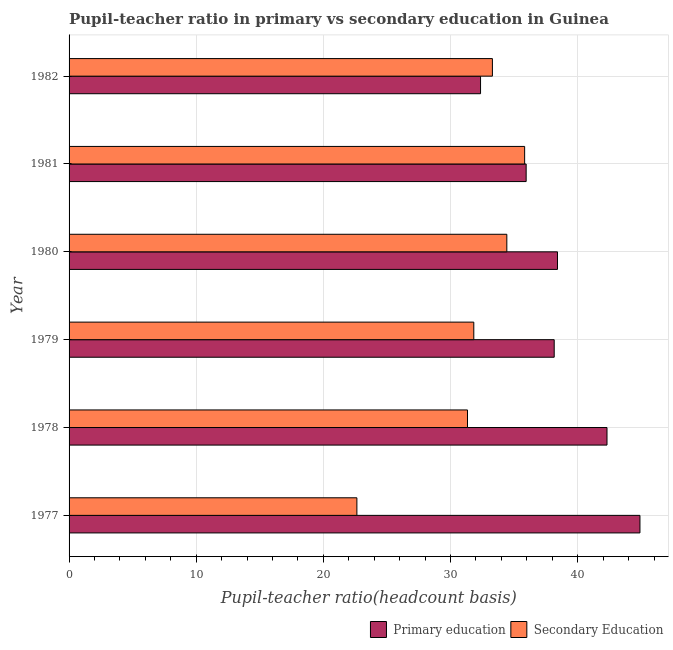How many different coloured bars are there?
Provide a succinct answer. 2. Are the number of bars per tick equal to the number of legend labels?
Give a very brief answer. Yes. How many bars are there on the 6th tick from the top?
Give a very brief answer. 2. How many bars are there on the 5th tick from the bottom?
Offer a terse response. 2. What is the label of the 6th group of bars from the top?
Ensure brevity in your answer.  1977. In how many cases, is the number of bars for a given year not equal to the number of legend labels?
Offer a very short reply. 0. What is the pupil teacher ratio on secondary education in 1982?
Keep it short and to the point. 33.29. Across all years, what is the maximum pupil teacher ratio on secondary education?
Keep it short and to the point. 35.83. Across all years, what is the minimum pupil teacher ratio on secondary education?
Keep it short and to the point. 22.63. In which year was the pupil-teacher ratio in primary education maximum?
Ensure brevity in your answer.  1977. What is the total pupil-teacher ratio in primary education in the graph?
Provide a short and direct response. 232.06. What is the difference between the pupil teacher ratio on secondary education in 1977 and that in 1978?
Offer a very short reply. -8.7. What is the difference between the pupil-teacher ratio in primary education in 1979 and the pupil teacher ratio on secondary education in 1978?
Your answer should be very brief. 6.82. What is the average pupil teacher ratio on secondary education per year?
Offer a terse response. 31.56. In the year 1977, what is the difference between the pupil teacher ratio on secondary education and pupil-teacher ratio in primary education?
Ensure brevity in your answer.  -22.26. What is the ratio of the pupil-teacher ratio in primary education in 1979 to that in 1982?
Your answer should be very brief. 1.18. Is the difference between the pupil-teacher ratio in primary education in 1977 and 1979 greater than the difference between the pupil teacher ratio on secondary education in 1977 and 1979?
Your answer should be very brief. Yes. What is the difference between the highest and the second highest pupil-teacher ratio in primary education?
Provide a short and direct response. 2.59. What is the difference between the highest and the lowest pupil-teacher ratio in primary education?
Give a very brief answer. 12.54. In how many years, is the pupil teacher ratio on secondary education greater than the average pupil teacher ratio on secondary education taken over all years?
Provide a short and direct response. 4. What does the 2nd bar from the bottom in 1979 represents?
Provide a succinct answer. Secondary Education. How many bars are there?
Ensure brevity in your answer.  12. What is the difference between two consecutive major ticks on the X-axis?
Your response must be concise. 10. Are the values on the major ticks of X-axis written in scientific E-notation?
Your answer should be very brief. No. Does the graph contain grids?
Your answer should be compact. Yes. Where does the legend appear in the graph?
Keep it short and to the point. Bottom right. How are the legend labels stacked?
Your response must be concise. Horizontal. What is the title of the graph?
Provide a short and direct response. Pupil-teacher ratio in primary vs secondary education in Guinea. Does "Canada" appear as one of the legend labels in the graph?
Keep it short and to the point. No. What is the label or title of the X-axis?
Keep it short and to the point. Pupil-teacher ratio(headcount basis). What is the Pupil-teacher ratio(headcount basis) of Primary education in 1977?
Your answer should be compact. 44.89. What is the Pupil-teacher ratio(headcount basis) in Secondary Education in 1977?
Make the answer very short. 22.63. What is the Pupil-teacher ratio(headcount basis) of Primary education in 1978?
Your answer should be very brief. 42.3. What is the Pupil-teacher ratio(headcount basis) in Secondary Education in 1978?
Your answer should be very brief. 31.33. What is the Pupil-teacher ratio(headcount basis) of Primary education in 1979?
Give a very brief answer. 38.15. What is the Pupil-teacher ratio(headcount basis) in Secondary Education in 1979?
Keep it short and to the point. 31.83. What is the Pupil-teacher ratio(headcount basis) of Primary education in 1980?
Keep it short and to the point. 38.41. What is the Pupil-teacher ratio(headcount basis) of Secondary Education in 1980?
Your answer should be compact. 34.43. What is the Pupil-teacher ratio(headcount basis) in Primary education in 1981?
Your answer should be very brief. 35.95. What is the Pupil-teacher ratio(headcount basis) in Secondary Education in 1981?
Provide a succinct answer. 35.83. What is the Pupil-teacher ratio(headcount basis) of Primary education in 1982?
Your answer should be very brief. 32.36. What is the Pupil-teacher ratio(headcount basis) of Secondary Education in 1982?
Make the answer very short. 33.29. Across all years, what is the maximum Pupil-teacher ratio(headcount basis) of Primary education?
Offer a very short reply. 44.89. Across all years, what is the maximum Pupil-teacher ratio(headcount basis) of Secondary Education?
Offer a very short reply. 35.83. Across all years, what is the minimum Pupil-teacher ratio(headcount basis) in Primary education?
Your response must be concise. 32.36. Across all years, what is the minimum Pupil-teacher ratio(headcount basis) in Secondary Education?
Offer a very short reply. 22.63. What is the total Pupil-teacher ratio(headcount basis) in Primary education in the graph?
Your answer should be compact. 232.06. What is the total Pupil-teacher ratio(headcount basis) in Secondary Education in the graph?
Provide a short and direct response. 189.34. What is the difference between the Pupil-teacher ratio(headcount basis) of Primary education in 1977 and that in 1978?
Your answer should be compact. 2.59. What is the difference between the Pupil-teacher ratio(headcount basis) in Secondary Education in 1977 and that in 1978?
Your answer should be compact. -8.7. What is the difference between the Pupil-teacher ratio(headcount basis) of Primary education in 1977 and that in 1979?
Give a very brief answer. 6.74. What is the difference between the Pupil-teacher ratio(headcount basis) in Secondary Education in 1977 and that in 1979?
Give a very brief answer. -9.19. What is the difference between the Pupil-teacher ratio(headcount basis) in Primary education in 1977 and that in 1980?
Offer a very short reply. 6.49. What is the difference between the Pupil-teacher ratio(headcount basis) of Secondary Education in 1977 and that in 1980?
Provide a short and direct response. -11.79. What is the difference between the Pupil-teacher ratio(headcount basis) of Primary education in 1977 and that in 1981?
Provide a succinct answer. 8.95. What is the difference between the Pupil-teacher ratio(headcount basis) of Secondary Education in 1977 and that in 1981?
Make the answer very short. -13.19. What is the difference between the Pupil-teacher ratio(headcount basis) of Primary education in 1977 and that in 1982?
Offer a terse response. 12.54. What is the difference between the Pupil-teacher ratio(headcount basis) in Secondary Education in 1977 and that in 1982?
Give a very brief answer. -10.66. What is the difference between the Pupil-teacher ratio(headcount basis) of Primary education in 1978 and that in 1979?
Ensure brevity in your answer.  4.15. What is the difference between the Pupil-teacher ratio(headcount basis) of Secondary Education in 1978 and that in 1979?
Make the answer very short. -0.49. What is the difference between the Pupil-teacher ratio(headcount basis) in Primary education in 1978 and that in 1980?
Provide a short and direct response. 3.89. What is the difference between the Pupil-teacher ratio(headcount basis) in Secondary Education in 1978 and that in 1980?
Your answer should be very brief. -3.09. What is the difference between the Pupil-teacher ratio(headcount basis) in Primary education in 1978 and that in 1981?
Provide a short and direct response. 6.36. What is the difference between the Pupil-teacher ratio(headcount basis) of Secondary Education in 1978 and that in 1981?
Provide a short and direct response. -4.49. What is the difference between the Pupil-teacher ratio(headcount basis) in Primary education in 1978 and that in 1982?
Provide a short and direct response. 9.94. What is the difference between the Pupil-teacher ratio(headcount basis) of Secondary Education in 1978 and that in 1982?
Give a very brief answer. -1.96. What is the difference between the Pupil-teacher ratio(headcount basis) in Primary education in 1979 and that in 1980?
Your answer should be very brief. -0.26. What is the difference between the Pupil-teacher ratio(headcount basis) of Secondary Education in 1979 and that in 1980?
Provide a succinct answer. -2.6. What is the difference between the Pupil-teacher ratio(headcount basis) of Primary education in 1979 and that in 1981?
Provide a succinct answer. 2.21. What is the difference between the Pupil-teacher ratio(headcount basis) in Secondary Education in 1979 and that in 1981?
Make the answer very short. -4. What is the difference between the Pupil-teacher ratio(headcount basis) in Primary education in 1979 and that in 1982?
Make the answer very short. 5.79. What is the difference between the Pupil-teacher ratio(headcount basis) of Secondary Education in 1979 and that in 1982?
Offer a terse response. -1.46. What is the difference between the Pupil-teacher ratio(headcount basis) of Primary education in 1980 and that in 1981?
Ensure brevity in your answer.  2.46. What is the difference between the Pupil-teacher ratio(headcount basis) of Secondary Education in 1980 and that in 1981?
Provide a short and direct response. -1.4. What is the difference between the Pupil-teacher ratio(headcount basis) of Primary education in 1980 and that in 1982?
Offer a terse response. 6.05. What is the difference between the Pupil-teacher ratio(headcount basis) in Secondary Education in 1980 and that in 1982?
Make the answer very short. 1.13. What is the difference between the Pupil-teacher ratio(headcount basis) in Primary education in 1981 and that in 1982?
Provide a succinct answer. 3.59. What is the difference between the Pupil-teacher ratio(headcount basis) of Secondary Education in 1981 and that in 1982?
Provide a succinct answer. 2.53. What is the difference between the Pupil-teacher ratio(headcount basis) in Primary education in 1977 and the Pupil-teacher ratio(headcount basis) in Secondary Education in 1978?
Make the answer very short. 13.56. What is the difference between the Pupil-teacher ratio(headcount basis) of Primary education in 1977 and the Pupil-teacher ratio(headcount basis) of Secondary Education in 1979?
Make the answer very short. 13.07. What is the difference between the Pupil-teacher ratio(headcount basis) of Primary education in 1977 and the Pupil-teacher ratio(headcount basis) of Secondary Education in 1980?
Your response must be concise. 10.47. What is the difference between the Pupil-teacher ratio(headcount basis) of Primary education in 1977 and the Pupil-teacher ratio(headcount basis) of Secondary Education in 1981?
Your answer should be compact. 9.07. What is the difference between the Pupil-teacher ratio(headcount basis) in Primary education in 1977 and the Pupil-teacher ratio(headcount basis) in Secondary Education in 1982?
Offer a terse response. 11.6. What is the difference between the Pupil-teacher ratio(headcount basis) of Primary education in 1978 and the Pupil-teacher ratio(headcount basis) of Secondary Education in 1979?
Offer a very short reply. 10.48. What is the difference between the Pupil-teacher ratio(headcount basis) of Primary education in 1978 and the Pupil-teacher ratio(headcount basis) of Secondary Education in 1980?
Provide a succinct answer. 7.88. What is the difference between the Pupil-teacher ratio(headcount basis) of Primary education in 1978 and the Pupil-teacher ratio(headcount basis) of Secondary Education in 1981?
Your answer should be very brief. 6.48. What is the difference between the Pupil-teacher ratio(headcount basis) of Primary education in 1978 and the Pupil-teacher ratio(headcount basis) of Secondary Education in 1982?
Your response must be concise. 9.01. What is the difference between the Pupil-teacher ratio(headcount basis) of Primary education in 1979 and the Pupil-teacher ratio(headcount basis) of Secondary Education in 1980?
Give a very brief answer. 3.73. What is the difference between the Pupil-teacher ratio(headcount basis) in Primary education in 1979 and the Pupil-teacher ratio(headcount basis) in Secondary Education in 1981?
Your answer should be very brief. 2.32. What is the difference between the Pupil-teacher ratio(headcount basis) in Primary education in 1979 and the Pupil-teacher ratio(headcount basis) in Secondary Education in 1982?
Offer a terse response. 4.86. What is the difference between the Pupil-teacher ratio(headcount basis) of Primary education in 1980 and the Pupil-teacher ratio(headcount basis) of Secondary Education in 1981?
Ensure brevity in your answer.  2.58. What is the difference between the Pupil-teacher ratio(headcount basis) in Primary education in 1980 and the Pupil-teacher ratio(headcount basis) in Secondary Education in 1982?
Ensure brevity in your answer.  5.12. What is the difference between the Pupil-teacher ratio(headcount basis) of Primary education in 1981 and the Pupil-teacher ratio(headcount basis) of Secondary Education in 1982?
Your response must be concise. 2.65. What is the average Pupil-teacher ratio(headcount basis) in Primary education per year?
Offer a very short reply. 38.68. What is the average Pupil-teacher ratio(headcount basis) in Secondary Education per year?
Make the answer very short. 31.56. In the year 1977, what is the difference between the Pupil-teacher ratio(headcount basis) of Primary education and Pupil-teacher ratio(headcount basis) of Secondary Education?
Give a very brief answer. 22.26. In the year 1978, what is the difference between the Pupil-teacher ratio(headcount basis) in Primary education and Pupil-teacher ratio(headcount basis) in Secondary Education?
Provide a short and direct response. 10.97. In the year 1979, what is the difference between the Pupil-teacher ratio(headcount basis) in Primary education and Pupil-teacher ratio(headcount basis) in Secondary Education?
Provide a succinct answer. 6.32. In the year 1980, what is the difference between the Pupil-teacher ratio(headcount basis) in Primary education and Pupil-teacher ratio(headcount basis) in Secondary Education?
Ensure brevity in your answer.  3.98. In the year 1981, what is the difference between the Pupil-teacher ratio(headcount basis) in Primary education and Pupil-teacher ratio(headcount basis) in Secondary Education?
Your answer should be compact. 0.12. In the year 1982, what is the difference between the Pupil-teacher ratio(headcount basis) of Primary education and Pupil-teacher ratio(headcount basis) of Secondary Education?
Give a very brief answer. -0.93. What is the ratio of the Pupil-teacher ratio(headcount basis) in Primary education in 1977 to that in 1978?
Your response must be concise. 1.06. What is the ratio of the Pupil-teacher ratio(headcount basis) in Secondary Education in 1977 to that in 1978?
Offer a very short reply. 0.72. What is the ratio of the Pupil-teacher ratio(headcount basis) in Primary education in 1977 to that in 1979?
Give a very brief answer. 1.18. What is the ratio of the Pupil-teacher ratio(headcount basis) in Secondary Education in 1977 to that in 1979?
Provide a succinct answer. 0.71. What is the ratio of the Pupil-teacher ratio(headcount basis) in Primary education in 1977 to that in 1980?
Your answer should be very brief. 1.17. What is the ratio of the Pupil-teacher ratio(headcount basis) of Secondary Education in 1977 to that in 1980?
Your answer should be very brief. 0.66. What is the ratio of the Pupil-teacher ratio(headcount basis) in Primary education in 1977 to that in 1981?
Offer a very short reply. 1.25. What is the ratio of the Pupil-teacher ratio(headcount basis) in Secondary Education in 1977 to that in 1981?
Offer a terse response. 0.63. What is the ratio of the Pupil-teacher ratio(headcount basis) in Primary education in 1977 to that in 1982?
Make the answer very short. 1.39. What is the ratio of the Pupil-teacher ratio(headcount basis) of Secondary Education in 1977 to that in 1982?
Offer a terse response. 0.68. What is the ratio of the Pupil-teacher ratio(headcount basis) of Primary education in 1978 to that in 1979?
Offer a terse response. 1.11. What is the ratio of the Pupil-teacher ratio(headcount basis) in Secondary Education in 1978 to that in 1979?
Provide a succinct answer. 0.98. What is the ratio of the Pupil-teacher ratio(headcount basis) of Primary education in 1978 to that in 1980?
Your answer should be compact. 1.1. What is the ratio of the Pupil-teacher ratio(headcount basis) in Secondary Education in 1978 to that in 1980?
Give a very brief answer. 0.91. What is the ratio of the Pupil-teacher ratio(headcount basis) in Primary education in 1978 to that in 1981?
Your response must be concise. 1.18. What is the ratio of the Pupil-teacher ratio(headcount basis) in Secondary Education in 1978 to that in 1981?
Keep it short and to the point. 0.87. What is the ratio of the Pupil-teacher ratio(headcount basis) of Primary education in 1978 to that in 1982?
Offer a very short reply. 1.31. What is the ratio of the Pupil-teacher ratio(headcount basis) of Primary education in 1979 to that in 1980?
Your response must be concise. 0.99. What is the ratio of the Pupil-teacher ratio(headcount basis) in Secondary Education in 1979 to that in 1980?
Keep it short and to the point. 0.92. What is the ratio of the Pupil-teacher ratio(headcount basis) of Primary education in 1979 to that in 1981?
Make the answer very short. 1.06. What is the ratio of the Pupil-teacher ratio(headcount basis) of Secondary Education in 1979 to that in 1981?
Offer a very short reply. 0.89. What is the ratio of the Pupil-teacher ratio(headcount basis) in Primary education in 1979 to that in 1982?
Your response must be concise. 1.18. What is the ratio of the Pupil-teacher ratio(headcount basis) in Secondary Education in 1979 to that in 1982?
Keep it short and to the point. 0.96. What is the ratio of the Pupil-teacher ratio(headcount basis) of Primary education in 1980 to that in 1981?
Provide a short and direct response. 1.07. What is the ratio of the Pupil-teacher ratio(headcount basis) of Secondary Education in 1980 to that in 1981?
Your answer should be compact. 0.96. What is the ratio of the Pupil-teacher ratio(headcount basis) in Primary education in 1980 to that in 1982?
Your answer should be very brief. 1.19. What is the ratio of the Pupil-teacher ratio(headcount basis) of Secondary Education in 1980 to that in 1982?
Your answer should be compact. 1.03. What is the ratio of the Pupil-teacher ratio(headcount basis) in Primary education in 1981 to that in 1982?
Provide a short and direct response. 1.11. What is the ratio of the Pupil-teacher ratio(headcount basis) of Secondary Education in 1981 to that in 1982?
Keep it short and to the point. 1.08. What is the difference between the highest and the second highest Pupil-teacher ratio(headcount basis) in Primary education?
Make the answer very short. 2.59. What is the difference between the highest and the second highest Pupil-teacher ratio(headcount basis) of Secondary Education?
Keep it short and to the point. 1.4. What is the difference between the highest and the lowest Pupil-teacher ratio(headcount basis) of Primary education?
Provide a succinct answer. 12.54. What is the difference between the highest and the lowest Pupil-teacher ratio(headcount basis) in Secondary Education?
Provide a short and direct response. 13.19. 